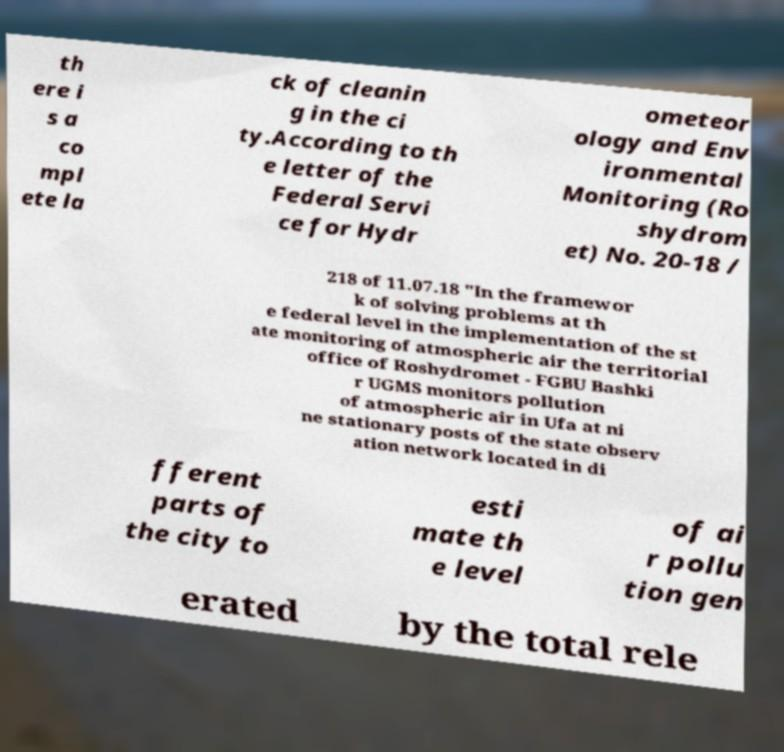What messages or text are displayed in this image? I need them in a readable, typed format. th ere i s a co mpl ete la ck of cleanin g in the ci ty.According to th e letter of the Federal Servi ce for Hydr ometeor ology and Env ironmental Monitoring (Ro shydrom et) No. 20-18 / 218 of 11.07.18 "In the framewor k of solving problems at th e federal level in the implementation of the st ate monitoring of atmospheric air the territorial office of Roshydromet - FGBU Bashki r UGMS monitors pollution of atmospheric air in Ufa at ni ne stationary posts of the state observ ation network located in di fferent parts of the city to esti mate th e level of ai r pollu tion gen erated by the total rele 